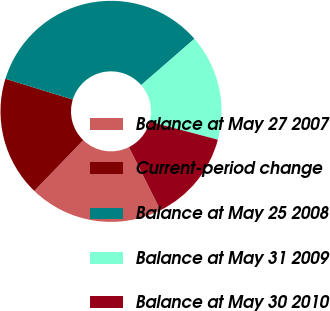Convert chart to OTSL. <chart><loc_0><loc_0><loc_500><loc_500><pie_chart><fcel>Balance at May 27 2007<fcel>Current-period change<fcel>Balance at May 25 2008<fcel>Balance at May 31 2009<fcel>Balance at May 30 2010<nl><fcel>19.59%<fcel>17.56%<fcel>33.84%<fcel>15.52%<fcel>13.49%<nl></chart> 